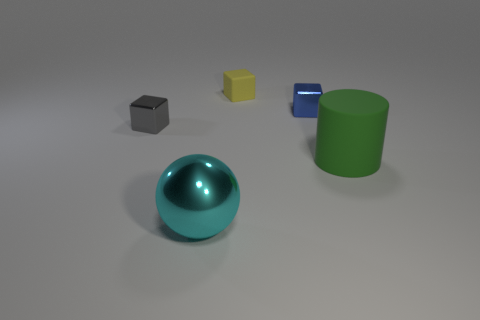Can you describe the different shapes and colors of the objects in the image? Certainly! The image displays a collection of objects with varying shapes and colors. There is a spherical object with a shiny teal surface, a cube that is gray, another cube that is blue, a yellow rectangular prism, and a cylindrical object with a green surface. The objects are arranged on a neutral background, allowing their distinct colors and shapes to stand out prominently. 